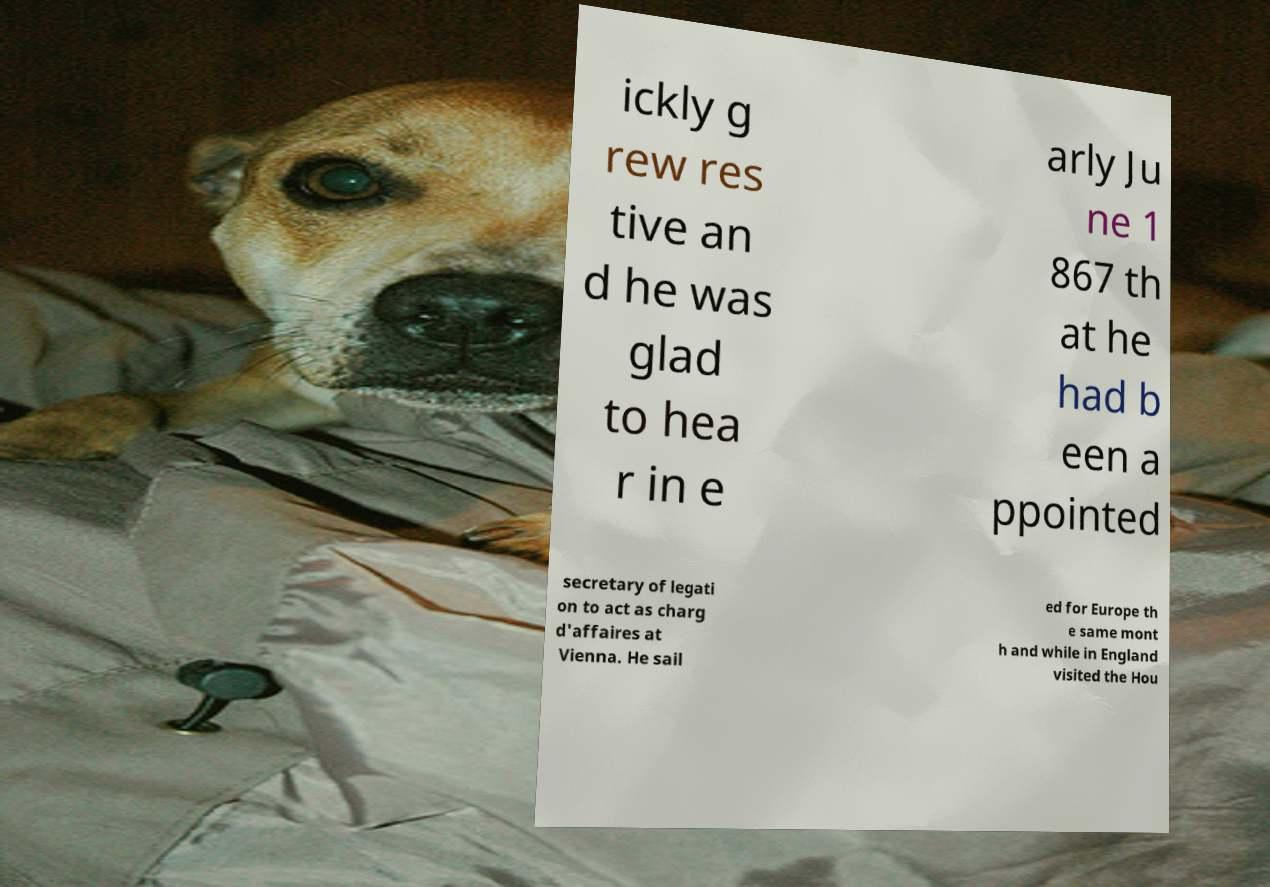I need the written content from this picture converted into text. Can you do that? ickly g rew res tive an d he was glad to hea r in e arly Ju ne 1 867 th at he had b een a ppointed secretary of legati on to act as charg d'affaires at Vienna. He sail ed for Europe th e same mont h and while in England visited the Hou 